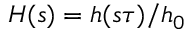Convert formula to latex. <formula><loc_0><loc_0><loc_500><loc_500>H ( s ) = h ( s \tau ) / h _ { 0 }</formula> 